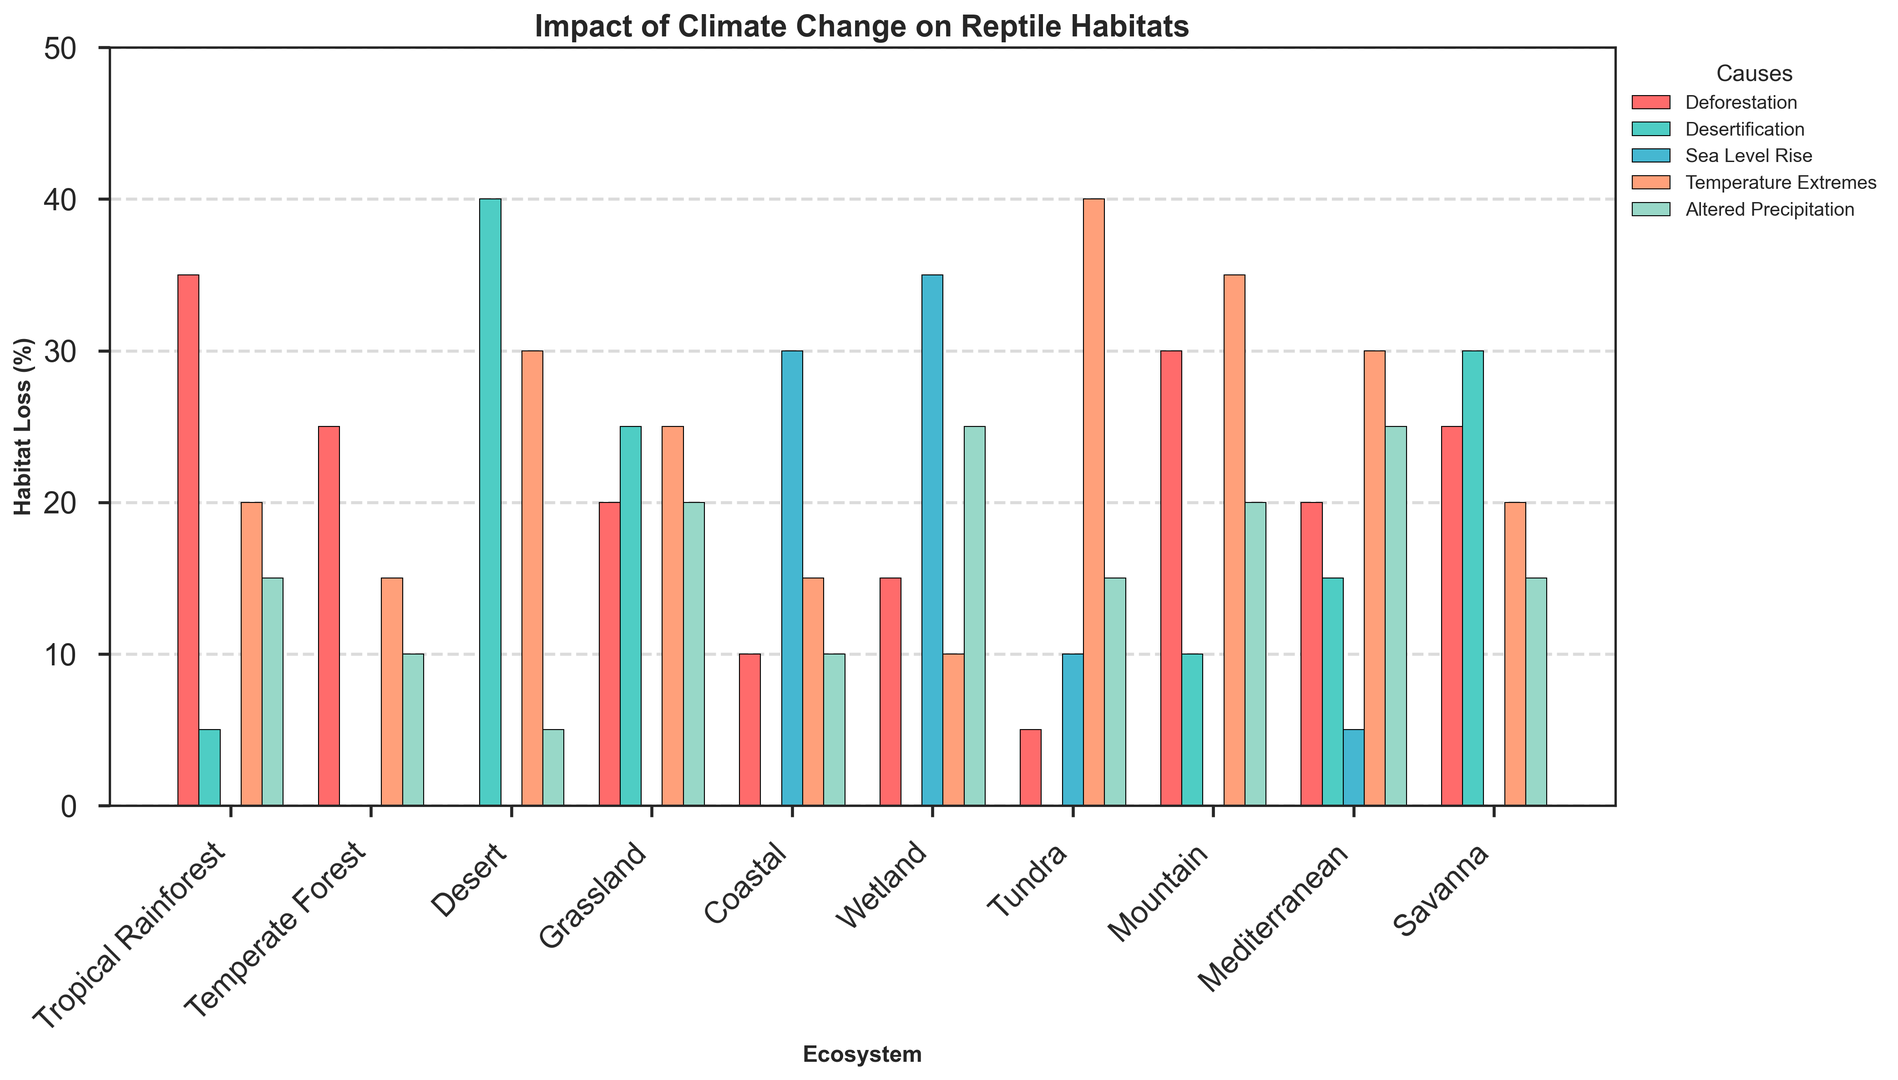Which ecosystem experiences the highest habitat loss due to deforestation? Observing the figure, the Tropical Rainforest has the tallest bar in the deforestation category (colored in red).
Answer: Tropical Rainforest Which ecosystem has the least habitat loss due to sea level rise? By looking at the sea level rise category (colored in blue), the Tropical Rainforest, Temperate Forest, Desert, Grassland, Mountain, and Savanna ecosystems all show no bars, indicating 0%. Therefore, these ecosystems tie for the least habitat loss.
Answer: Tropical Rainforest, Temperate Forest, Desert, Grassland, Mountain, Savanna Among Temperate Forest and Coastal ecosystems, which one suffers more from altered precipitation? The Coastal ecosystem has a higher bar for altered precipitation (colored in green) compared to the Temperate Forest. Thus, Coastal suffers more.
Answer: Coastal Which ecosystem has the highest combined habitat loss due to temperature extremes and altered precipitation? Summing the values for temperature extremes (orange) and altered precipitation (green) across each ecosystem:
- Tropical Rainforest: 20 + 15 = 35
- Temperate Forest: 15 + 10 = 25
- Desert: 30 + 5 = 35
- Grassland: 25 + 20 = 45
- Coastal: 15 + 10 = 25
- Wetland: 10 + 25 = 35
- Tundra: 40 + 15 = 55
- Mountain: 35 + 20 = 55
- Mediterranean: 30 + 25 = 55
- Savanna: 20 + 15 = 35
Tundra, Mountain, and Mediterranean ecosystems each have a combined value of 55, which is the highest.
Answer: Tundra, Mountain, Mediterranean What is the difference in habitat loss due to desertification between the Desert and Grassland ecosystems? The habitat loss due to desertification (colored in green) for Desert is 40 and for Grassland is 25. The difference is 40 - 25 = 15.
Answer: 15 Which cause of habitat loss is the least impacting the Tundra ecosystem? For the Tundra ecosystem, the smallest bar is for deforestation (5%) among the five causes.
Answer: Deforestation How does habitat loss due to deforestation in the Mediterranean ecosystem compare to the Coastal ecosystem? Observing the bars for deforestation, the Mediterranean (red) has a taller bar at 20%, while the Coastal is shorter at 10%. So, the Mediterranean has higher habitat loss due to deforestation.
Answer: Mediterranean What's the average habitat loss due to altered precipitation across all ecosystems? Adding up the habitat loss values for altered precipitation (15 + 10 + 5 + 20 + 10 + 25 + 15 + 20 + 25 + 15) = 160; then dividing by the number of ecosystems (10): 160 / 10 = 16.
Answer: 16 Which ecosystem has the highest habitat loss attributable to sea level rise? Observing the figure, the Wetland ecosystem has the tallest bar in the sea level rise category (colored in blue), at 35%.
Answer: Wetland 